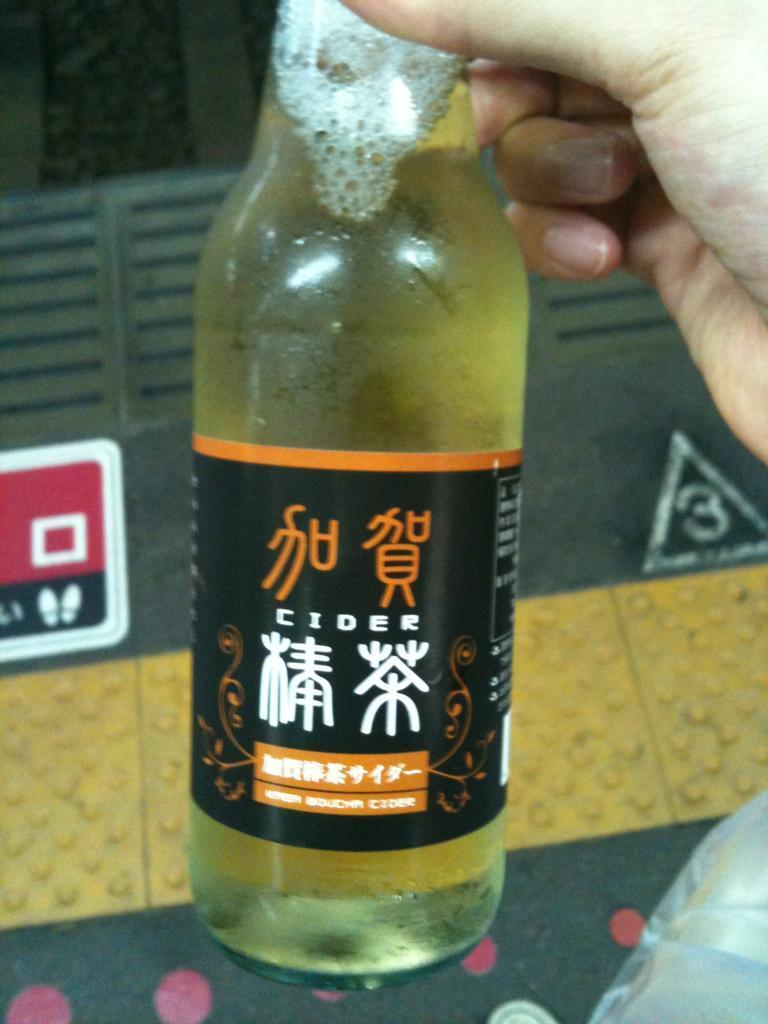<image>
Relay a brief, clear account of the picture shown. A bottle of Chinese Cider is being held near the number 3 